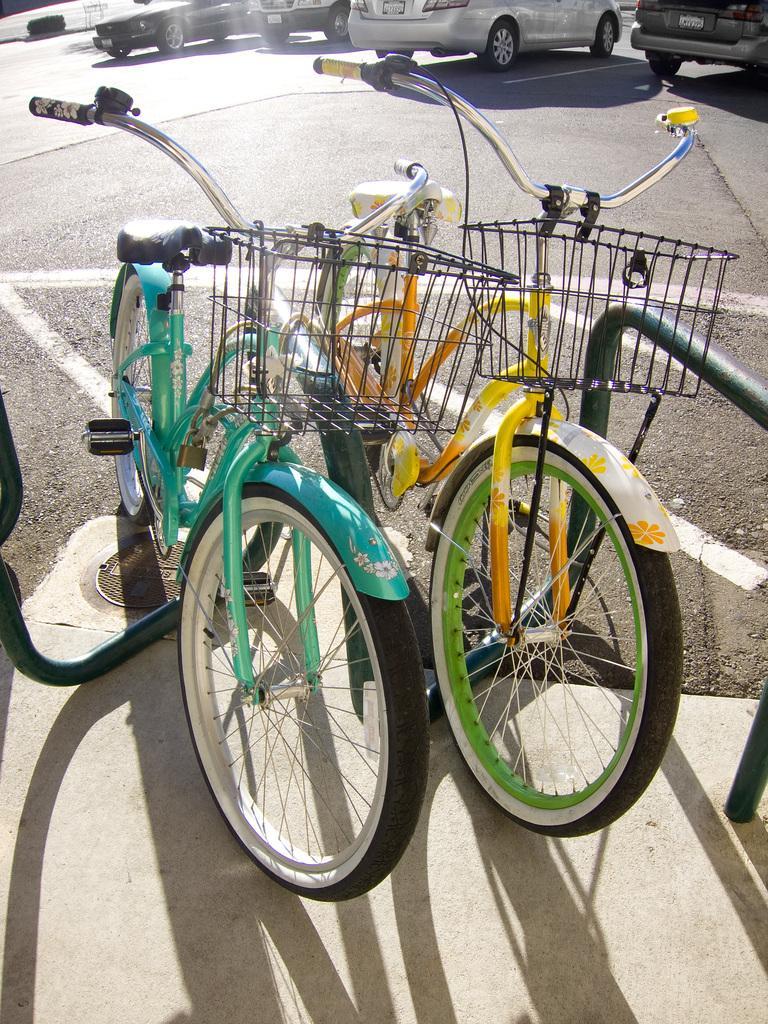Describe this image in one or two sentences. In this image there are a few bicycles parked, beside the bicycles there is a metal structure. In the background there are a few vehicles parked on the road. 